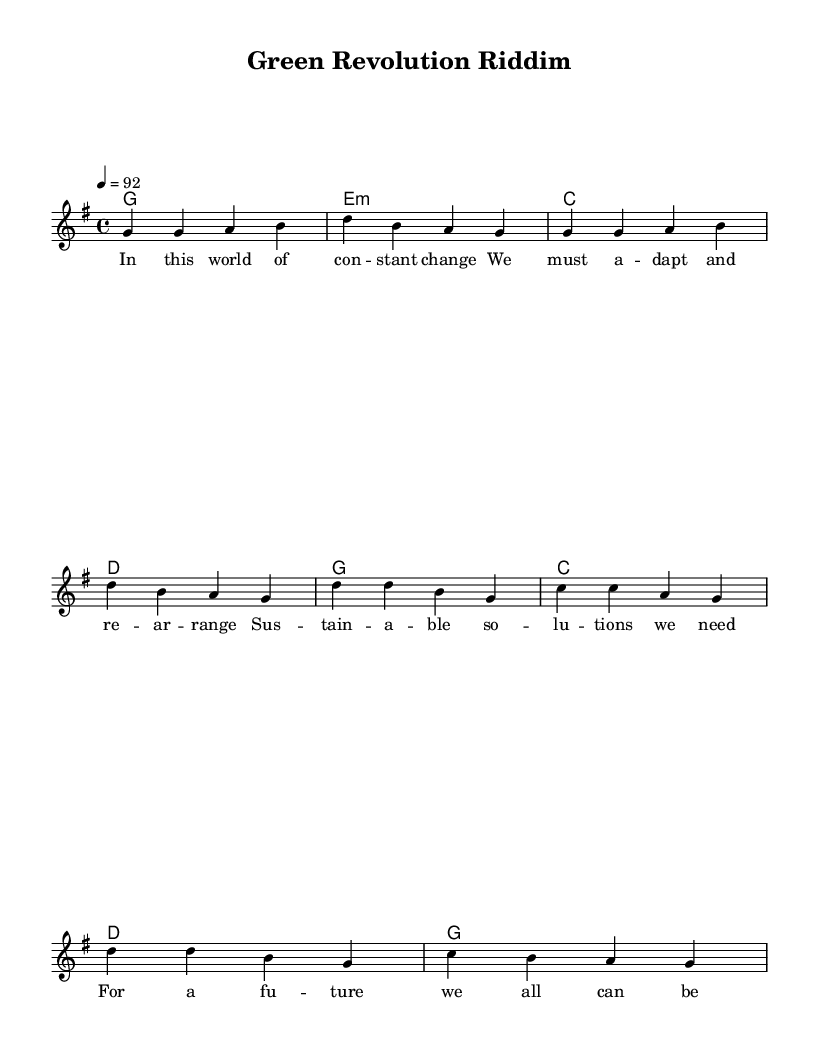What is the key signature of this music? The key signature is G major, which has one sharp. This can be identified by looking at the key signature at the beginning of the staff notation.
Answer: G major What is the time signature of this piece? The time signature is 4/4, as indicated at the beginning of the sheet music. This means there are four beats in a measure, and the quarter note gets one beat.
Answer: 4/4 What is the tempo marking for this music? The tempo marking is 92 beats per minute, as indicated in the tempo section at the beginning. This tells performers how quickly to play the piece.
Answer: 92 How many measures are in the verse section? The verse section contains four measures, which can be counted by looking at the bar lines in the melody that correspond to the lyrics.
Answer: Four What is the main theme of the chorus lyrics? The main theme of the chorus lyrics is promoting eco-friendly policies and starting a green revolution, as reflected in the wording of the lyrics.
Answer: Eco-friendly policies What type of chord is used in the second measure? The chord used in the second measure is E minor, which is indicated in the chord changes notated below the staff.
Answer: E minor What music genre does this sheet music represent? This sheet music represents the Reggae genre, characterized by its laid-back rhythm and focus on social themes, including sustainable development.
Answer: Reggae 